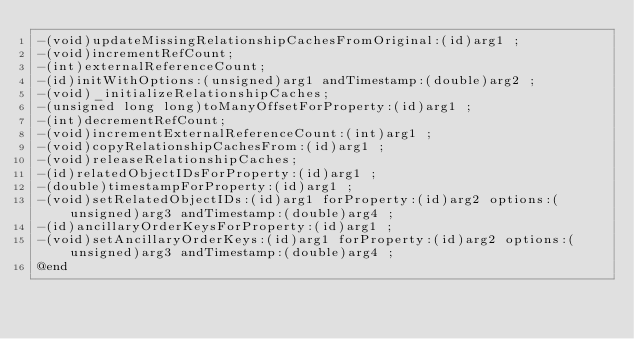<code> <loc_0><loc_0><loc_500><loc_500><_C_>-(void)updateMissingRelationshipCachesFromOriginal:(id)arg1 ;
-(void)incrementRefCount;
-(int)externalReferenceCount;
-(id)initWithOptions:(unsigned)arg1 andTimestamp:(double)arg2 ;
-(void)_initializeRelationshipCaches;
-(unsigned long long)toManyOffsetForProperty:(id)arg1 ;
-(int)decrementRefCount;
-(void)incrementExternalReferenceCount:(int)arg1 ;
-(void)copyRelationshipCachesFrom:(id)arg1 ;
-(void)releaseRelationshipCaches;
-(id)relatedObjectIDsForProperty:(id)arg1 ;
-(double)timestampForProperty:(id)arg1 ;
-(void)setRelatedObjectIDs:(id)arg1 forProperty:(id)arg2 options:(unsigned)arg3 andTimestamp:(double)arg4 ;
-(id)ancillaryOrderKeysForProperty:(id)arg1 ;
-(void)setAncillaryOrderKeys:(id)arg1 forProperty:(id)arg2 options:(unsigned)arg3 andTimestamp:(double)arg4 ;
@end

</code> 